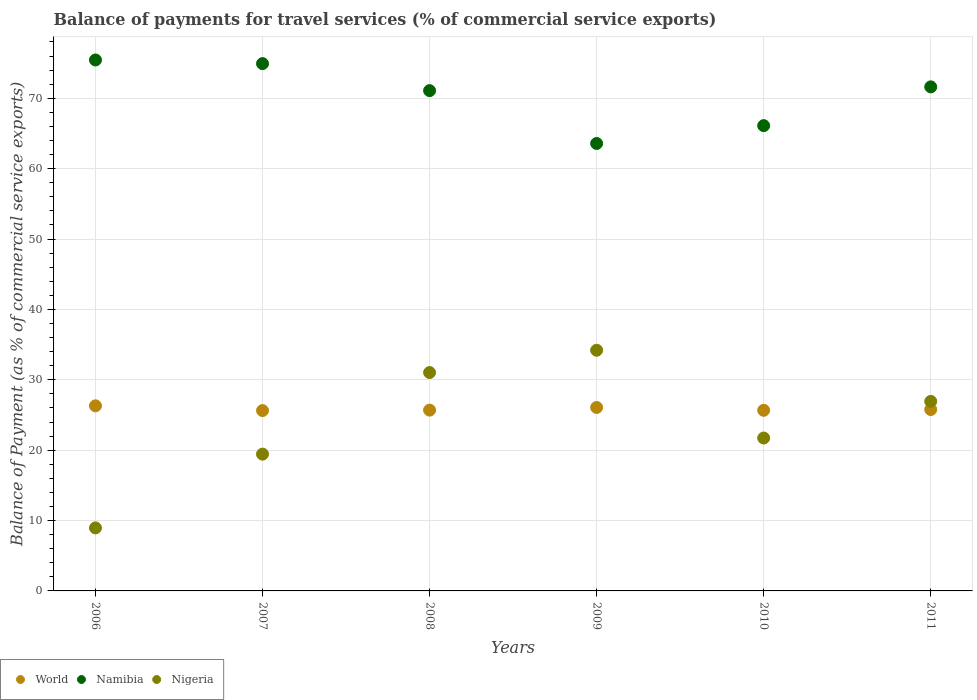How many different coloured dotlines are there?
Your response must be concise. 3. Is the number of dotlines equal to the number of legend labels?
Provide a succinct answer. Yes. What is the balance of payments for travel services in Namibia in 2009?
Keep it short and to the point. 63.58. Across all years, what is the maximum balance of payments for travel services in Nigeria?
Your response must be concise. 34.2. Across all years, what is the minimum balance of payments for travel services in Nigeria?
Make the answer very short. 8.96. In which year was the balance of payments for travel services in Namibia maximum?
Make the answer very short. 2006. In which year was the balance of payments for travel services in Nigeria minimum?
Make the answer very short. 2006. What is the total balance of payments for travel services in World in the graph?
Offer a terse response. 155.12. What is the difference between the balance of payments for travel services in Nigeria in 2008 and that in 2011?
Provide a succinct answer. 4.1. What is the difference between the balance of payments for travel services in World in 2011 and the balance of payments for travel services in Nigeria in 2008?
Your response must be concise. -5.25. What is the average balance of payments for travel services in Nigeria per year?
Make the answer very short. 23.71. In the year 2010, what is the difference between the balance of payments for travel services in World and balance of payments for travel services in Namibia?
Your response must be concise. -40.45. What is the ratio of the balance of payments for travel services in Namibia in 2006 to that in 2011?
Give a very brief answer. 1.05. Is the balance of payments for travel services in Namibia in 2009 less than that in 2011?
Ensure brevity in your answer.  Yes. What is the difference between the highest and the second highest balance of payments for travel services in Nigeria?
Keep it short and to the point. 3.17. What is the difference between the highest and the lowest balance of payments for travel services in Nigeria?
Keep it short and to the point. 25.24. Is the sum of the balance of payments for travel services in Nigeria in 2009 and 2011 greater than the maximum balance of payments for travel services in World across all years?
Give a very brief answer. Yes. Is it the case that in every year, the sum of the balance of payments for travel services in World and balance of payments for travel services in Nigeria  is greater than the balance of payments for travel services in Namibia?
Offer a terse response. No. Does the balance of payments for travel services in Namibia monotonically increase over the years?
Your response must be concise. No. Is the balance of payments for travel services in Namibia strictly less than the balance of payments for travel services in Nigeria over the years?
Give a very brief answer. No. How many years are there in the graph?
Provide a short and direct response. 6. What is the difference between two consecutive major ticks on the Y-axis?
Your answer should be very brief. 10. Are the values on the major ticks of Y-axis written in scientific E-notation?
Your response must be concise. No. Where does the legend appear in the graph?
Make the answer very short. Bottom left. How are the legend labels stacked?
Provide a succinct answer. Horizontal. What is the title of the graph?
Your answer should be very brief. Balance of payments for travel services (% of commercial service exports). What is the label or title of the X-axis?
Your answer should be very brief. Years. What is the label or title of the Y-axis?
Provide a succinct answer. Balance of Payment (as % of commercial service exports). What is the Balance of Payment (as % of commercial service exports) in World in 2006?
Provide a succinct answer. 26.3. What is the Balance of Payment (as % of commercial service exports) in Namibia in 2006?
Provide a succinct answer. 75.44. What is the Balance of Payment (as % of commercial service exports) in Nigeria in 2006?
Provide a succinct answer. 8.96. What is the Balance of Payment (as % of commercial service exports) in World in 2007?
Your answer should be very brief. 25.63. What is the Balance of Payment (as % of commercial service exports) of Namibia in 2007?
Your answer should be compact. 74.93. What is the Balance of Payment (as % of commercial service exports) in Nigeria in 2007?
Provide a short and direct response. 19.44. What is the Balance of Payment (as % of commercial service exports) in World in 2008?
Offer a terse response. 25.69. What is the Balance of Payment (as % of commercial service exports) of Namibia in 2008?
Your answer should be very brief. 71.09. What is the Balance of Payment (as % of commercial service exports) in Nigeria in 2008?
Your answer should be very brief. 31.03. What is the Balance of Payment (as % of commercial service exports) of World in 2009?
Make the answer very short. 26.07. What is the Balance of Payment (as % of commercial service exports) of Namibia in 2009?
Your answer should be compact. 63.58. What is the Balance of Payment (as % of commercial service exports) of Nigeria in 2009?
Your answer should be compact. 34.2. What is the Balance of Payment (as % of commercial service exports) of World in 2010?
Offer a very short reply. 25.66. What is the Balance of Payment (as % of commercial service exports) of Namibia in 2010?
Offer a very short reply. 66.11. What is the Balance of Payment (as % of commercial service exports) in Nigeria in 2010?
Your answer should be very brief. 21.73. What is the Balance of Payment (as % of commercial service exports) of World in 2011?
Your answer should be compact. 25.77. What is the Balance of Payment (as % of commercial service exports) of Namibia in 2011?
Provide a succinct answer. 71.62. What is the Balance of Payment (as % of commercial service exports) in Nigeria in 2011?
Your response must be concise. 26.93. Across all years, what is the maximum Balance of Payment (as % of commercial service exports) in World?
Ensure brevity in your answer.  26.3. Across all years, what is the maximum Balance of Payment (as % of commercial service exports) of Namibia?
Make the answer very short. 75.44. Across all years, what is the maximum Balance of Payment (as % of commercial service exports) in Nigeria?
Ensure brevity in your answer.  34.2. Across all years, what is the minimum Balance of Payment (as % of commercial service exports) in World?
Provide a short and direct response. 25.63. Across all years, what is the minimum Balance of Payment (as % of commercial service exports) of Namibia?
Your answer should be very brief. 63.58. Across all years, what is the minimum Balance of Payment (as % of commercial service exports) of Nigeria?
Your answer should be very brief. 8.96. What is the total Balance of Payment (as % of commercial service exports) in World in the graph?
Your response must be concise. 155.12. What is the total Balance of Payment (as % of commercial service exports) in Namibia in the graph?
Offer a terse response. 422.77. What is the total Balance of Payment (as % of commercial service exports) in Nigeria in the graph?
Your response must be concise. 142.28. What is the difference between the Balance of Payment (as % of commercial service exports) in World in 2006 and that in 2007?
Keep it short and to the point. 0.68. What is the difference between the Balance of Payment (as % of commercial service exports) of Namibia in 2006 and that in 2007?
Your answer should be very brief. 0.52. What is the difference between the Balance of Payment (as % of commercial service exports) in Nigeria in 2006 and that in 2007?
Offer a very short reply. -10.48. What is the difference between the Balance of Payment (as % of commercial service exports) in World in 2006 and that in 2008?
Give a very brief answer. 0.61. What is the difference between the Balance of Payment (as % of commercial service exports) of Namibia in 2006 and that in 2008?
Offer a very short reply. 4.36. What is the difference between the Balance of Payment (as % of commercial service exports) in Nigeria in 2006 and that in 2008?
Your answer should be very brief. -22.07. What is the difference between the Balance of Payment (as % of commercial service exports) of World in 2006 and that in 2009?
Provide a short and direct response. 0.24. What is the difference between the Balance of Payment (as % of commercial service exports) of Namibia in 2006 and that in 2009?
Provide a succinct answer. 11.86. What is the difference between the Balance of Payment (as % of commercial service exports) of Nigeria in 2006 and that in 2009?
Offer a terse response. -25.24. What is the difference between the Balance of Payment (as % of commercial service exports) in World in 2006 and that in 2010?
Offer a terse response. 0.64. What is the difference between the Balance of Payment (as % of commercial service exports) in Namibia in 2006 and that in 2010?
Provide a short and direct response. 9.33. What is the difference between the Balance of Payment (as % of commercial service exports) of Nigeria in 2006 and that in 2010?
Your response must be concise. -12.77. What is the difference between the Balance of Payment (as % of commercial service exports) of World in 2006 and that in 2011?
Make the answer very short. 0.53. What is the difference between the Balance of Payment (as % of commercial service exports) of Namibia in 2006 and that in 2011?
Keep it short and to the point. 3.82. What is the difference between the Balance of Payment (as % of commercial service exports) of Nigeria in 2006 and that in 2011?
Provide a succinct answer. -17.98. What is the difference between the Balance of Payment (as % of commercial service exports) of World in 2007 and that in 2008?
Your response must be concise. -0.06. What is the difference between the Balance of Payment (as % of commercial service exports) of Namibia in 2007 and that in 2008?
Provide a succinct answer. 3.84. What is the difference between the Balance of Payment (as % of commercial service exports) of Nigeria in 2007 and that in 2008?
Your response must be concise. -11.59. What is the difference between the Balance of Payment (as % of commercial service exports) of World in 2007 and that in 2009?
Your answer should be very brief. -0.44. What is the difference between the Balance of Payment (as % of commercial service exports) of Namibia in 2007 and that in 2009?
Your response must be concise. 11.35. What is the difference between the Balance of Payment (as % of commercial service exports) in Nigeria in 2007 and that in 2009?
Ensure brevity in your answer.  -14.76. What is the difference between the Balance of Payment (as % of commercial service exports) in World in 2007 and that in 2010?
Provide a short and direct response. -0.04. What is the difference between the Balance of Payment (as % of commercial service exports) of Namibia in 2007 and that in 2010?
Offer a very short reply. 8.81. What is the difference between the Balance of Payment (as % of commercial service exports) in Nigeria in 2007 and that in 2010?
Keep it short and to the point. -2.29. What is the difference between the Balance of Payment (as % of commercial service exports) in World in 2007 and that in 2011?
Keep it short and to the point. -0.15. What is the difference between the Balance of Payment (as % of commercial service exports) in Namibia in 2007 and that in 2011?
Your answer should be very brief. 3.3. What is the difference between the Balance of Payment (as % of commercial service exports) of Nigeria in 2007 and that in 2011?
Provide a succinct answer. -7.5. What is the difference between the Balance of Payment (as % of commercial service exports) in World in 2008 and that in 2009?
Your answer should be compact. -0.38. What is the difference between the Balance of Payment (as % of commercial service exports) of Namibia in 2008 and that in 2009?
Ensure brevity in your answer.  7.51. What is the difference between the Balance of Payment (as % of commercial service exports) of Nigeria in 2008 and that in 2009?
Your answer should be very brief. -3.17. What is the difference between the Balance of Payment (as % of commercial service exports) in World in 2008 and that in 2010?
Offer a very short reply. 0.03. What is the difference between the Balance of Payment (as % of commercial service exports) in Namibia in 2008 and that in 2010?
Your answer should be compact. 4.97. What is the difference between the Balance of Payment (as % of commercial service exports) in Nigeria in 2008 and that in 2010?
Your response must be concise. 9.3. What is the difference between the Balance of Payment (as % of commercial service exports) in World in 2008 and that in 2011?
Make the answer very short. -0.09. What is the difference between the Balance of Payment (as % of commercial service exports) of Namibia in 2008 and that in 2011?
Your answer should be very brief. -0.53. What is the difference between the Balance of Payment (as % of commercial service exports) of Nigeria in 2008 and that in 2011?
Give a very brief answer. 4.1. What is the difference between the Balance of Payment (as % of commercial service exports) in World in 2009 and that in 2010?
Ensure brevity in your answer.  0.4. What is the difference between the Balance of Payment (as % of commercial service exports) in Namibia in 2009 and that in 2010?
Your response must be concise. -2.53. What is the difference between the Balance of Payment (as % of commercial service exports) of Nigeria in 2009 and that in 2010?
Give a very brief answer. 12.47. What is the difference between the Balance of Payment (as % of commercial service exports) of World in 2009 and that in 2011?
Ensure brevity in your answer.  0.29. What is the difference between the Balance of Payment (as % of commercial service exports) of Namibia in 2009 and that in 2011?
Your response must be concise. -8.04. What is the difference between the Balance of Payment (as % of commercial service exports) of Nigeria in 2009 and that in 2011?
Keep it short and to the point. 7.27. What is the difference between the Balance of Payment (as % of commercial service exports) of World in 2010 and that in 2011?
Provide a short and direct response. -0.11. What is the difference between the Balance of Payment (as % of commercial service exports) of Namibia in 2010 and that in 2011?
Keep it short and to the point. -5.51. What is the difference between the Balance of Payment (as % of commercial service exports) in Nigeria in 2010 and that in 2011?
Make the answer very short. -5.21. What is the difference between the Balance of Payment (as % of commercial service exports) of World in 2006 and the Balance of Payment (as % of commercial service exports) of Namibia in 2007?
Make the answer very short. -48.62. What is the difference between the Balance of Payment (as % of commercial service exports) of World in 2006 and the Balance of Payment (as % of commercial service exports) of Nigeria in 2007?
Your response must be concise. 6.87. What is the difference between the Balance of Payment (as % of commercial service exports) in Namibia in 2006 and the Balance of Payment (as % of commercial service exports) in Nigeria in 2007?
Offer a very short reply. 56.01. What is the difference between the Balance of Payment (as % of commercial service exports) of World in 2006 and the Balance of Payment (as % of commercial service exports) of Namibia in 2008?
Keep it short and to the point. -44.78. What is the difference between the Balance of Payment (as % of commercial service exports) of World in 2006 and the Balance of Payment (as % of commercial service exports) of Nigeria in 2008?
Provide a succinct answer. -4.73. What is the difference between the Balance of Payment (as % of commercial service exports) of Namibia in 2006 and the Balance of Payment (as % of commercial service exports) of Nigeria in 2008?
Offer a very short reply. 44.41. What is the difference between the Balance of Payment (as % of commercial service exports) of World in 2006 and the Balance of Payment (as % of commercial service exports) of Namibia in 2009?
Keep it short and to the point. -37.28. What is the difference between the Balance of Payment (as % of commercial service exports) of World in 2006 and the Balance of Payment (as % of commercial service exports) of Nigeria in 2009?
Give a very brief answer. -7.9. What is the difference between the Balance of Payment (as % of commercial service exports) of Namibia in 2006 and the Balance of Payment (as % of commercial service exports) of Nigeria in 2009?
Your answer should be very brief. 41.25. What is the difference between the Balance of Payment (as % of commercial service exports) in World in 2006 and the Balance of Payment (as % of commercial service exports) in Namibia in 2010?
Keep it short and to the point. -39.81. What is the difference between the Balance of Payment (as % of commercial service exports) of World in 2006 and the Balance of Payment (as % of commercial service exports) of Nigeria in 2010?
Your response must be concise. 4.58. What is the difference between the Balance of Payment (as % of commercial service exports) of Namibia in 2006 and the Balance of Payment (as % of commercial service exports) of Nigeria in 2010?
Provide a succinct answer. 53.72. What is the difference between the Balance of Payment (as % of commercial service exports) of World in 2006 and the Balance of Payment (as % of commercial service exports) of Namibia in 2011?
Provide a succinct answer. -45.32. What is the difference between the Balance of Payment (as % of commercial service exports) of World in 2006 and the Balance of Payment (as % of commercial service exports) of Nigeria in 2011?
Your response must be concise. -0.63. What is the difference between the Balance of Payment (as % of commercial service exports) of Namibia in 2006 and the Balance of Payment (as % of commercial service exports) of Nigeria in 2011?
Keep it short and to the point. 48.51. What is the difference between the Balance of Payment (as % of commercial service exports) of World in 2007 and the Balance of Payment (as % of commercial service exports) of Namibia in 2008?
Provide a succinct answer. -45.46. What is the difference between the Balance of Payment (as % of commercial service exports) of World in 2007 and the Balance of Payment (as % of commercial service exports) of Nigeria in 2008?
Give a very brief answer. -5.4. What is the difference between the Balance of Payment (as % of commercial service exports) of Namibia in 2007 and the Balance of Payment (as % of commercial service exports) of Nigeria in 2008?
Offer a very short reply. 43.9. What is the difference between the Balance of Payment (as % of commercial service exports) of World in 2007 and the Balance of Payment (as % of commercial service exports) of Namibia in 2009?
Offer a terse response. -37.95. What is the difference between the Balance of Payment (as % of commercial service exports) of World in 2007 and the Balance of Payment (as % of commercial service exports) of Nigeria in 2009?
Keep it short and to the point. -8.57. What is the difference between the Balance of Payment (as % of commercial service exports) of Namibia in 2007 and the Balance of Payment (as % of commercial service exports) of Nigeria in 2009?
Provide a short and direct response. 40.73. What is the difference between the Balance of Payment (as % of commercial service exports) in World in 2007 and the Balance of Payment (as % of commercial service exports) in Namibia in 2010?
Ensure brevity in your answer.  -40.49. What is the difference between the Balance of Payment (as % of commercial service exports) in World in 2007 and the Balance of Payment (as % of commercial service exports) in Nigeria in 2010?
Your answer should be compact. 3.9. What is the difference between the Balance of Payment (as % of commercial service exports) in Namibia in 2007 and the Balance of Payment (as % of commercial service exports) in Nigeria in 2010?
Ensure brevity in your answer.  53.2. What is the difference between the Balance of Payment (as % of commercial service exports) of World in 2007 and the Balance of Payment (as % of commercial service exports) of Namibia in 2011?
Keep it short and to the point. -45.99. What is the difference between the Balance of Payment (as % of commercial service exports) of World in 2007 and the Balance of Payment (as % of commercial service exports) of Nigeria in 2011?
Provide a succinct answer. -1.31. What is the difference between the Balance of Payment (as % of commercial service exports) of Namibia in 2007 and the Balance of Payment (as % of commercial service exports) of Nigeria in 2011?
Your answer should be very brief. 47.99. What is the difference between the Balance of Payment (as % of commercial service exports) of World in 2008 and the Balance of Payment (as % of commercial service exports) of Namibia in 2009?
Ensure brevity in your answer.  -37.89. What is the difference between the Balance of Payment (as % of commercial service exports) in World in 2008 and the Balance of Payment (as % of commercial service exports) in Nigeria in 2009?
Your answer should be very brief. -8.51. What is the difference between the Balance of Payment (as % of commercial service exports) of Namibia in 2008 and the Balance of Payment (as % of commercial service exports) of Nigeria in 2009?
Offer a terse response. 36.89. What is the difference between the Balance of Payment (as % of commercial service exports) of World in 2008 and the Balance of Payment (as % of commercial service exports) of Namibia in 2010?
Make the answer very short. -40.42. What is the difference between the Balance of Payment (as % of commercial service exports) in World in 2008 and the Balance of Payment (as % of commercial service exports) in Nigeria in 2010?
Your answer should be very brief. 3.96. What is the difference between the Balance of Payment (as % of commercial service exports) in Namibia in 2008 and the Balance of Payment (as % of commercial service exports) in Nigeria in 2010?
Provide a short and direct response. 49.36. What is the difference between the Balance of Payment (as % of commercial service exports) of World in 2008 and the Balance of Payment (as % of commercial service exports) of Namibia in 2011?
Offer a very short reply. -45.93. What is the difference between the Balance of Payment (as % of commercial service exports) of World in 2008 and the Balance of Payment (as % of commercial service exports) of Nigeria in 2011?
Your answer should be very brief. -1.24. What is the difference between the Balance of Payment (as % of commercial service exports) of Namibia in 2008 and the Balance of Payment (as % of commercial service exports) of Nigeria in 2011?
Make the answer very short. 44.15. What is the difference between the Balance of Payment (as % of commercial service exports) of World in 2009 and the Balance of Payment (as % of commercial service exports) of Namibia in 2010?
Keep it short and to the point. -40.05. What is the difference between the Balance of Payment (as % of commercial service exports) in World in 2009 and the Balance of Payment (as % of commercial service exports) in Nigeria in 2010?
Make the answer very short. 4.34. What is the difference between the Balance of Payment (as % of commercial service exports) in Namibia in 2009 and the Balance of Payment (as % of commercial service exports) in Nigeria in 2010?
Your response must be concise. 41.85. What is the difference between the Balance of Payment (as % of commercial service exports) in World in 2009 and the Balance of Payment (as % of commercial service exports) in Namibia in 2011?
Your response must be concise. -45.55. What is the difference between the Balance of Payment (as % of commercial service exports) in World in 2009 and the Balance of Payment (as % of commercial service exports) in Nigeria in 2011?
Ensure brevity in your answer.  -0.87. What is the difference between the Balance of Payment (as % of commercial service exports) of Namibia in 2009 and the Balance of Payment (as % of commercial service exports) of Nigeria in 2011?
Your answer should be very brief. 36.65. What is the difference between the Balance of Payment (as % of commercial service exports) of World in 2010 and the Balance of Payment (as % of commercial service exports) of Namibia in 2011?
Provide a short and direct response. -45.96. What is the difference between the Balance of Payment (as % of commercial service exports) in World in 2010 and the Balance of Payment (as % of commercial service exports) in Nigeria in 2011?
Make the answer very short. -1.27. What is the difference between the Balance of Payment (as % of commercial service exports) in Namibia in 2010 and the Balance of Payment (as % of commercial service exports) in Nigeria in 2011?
Your answer should be compact. 39.18. What is the average Balance of Payment (as % of commercial service exports) in World per year?
Keep it short and to the point. 25.85. What is the average Balance of Payment (as % of commercial service exports) of Namibia per year?
Your answer should be very brief. 70.46. What is the average Balance of Payment (as % of commercial service exports) in Nigeria per year?
Provide a succinct answer. 23.71. In the year 2006, what is the difference between the Balance of Payment (as % of commercial service exports) in World and Balance of Payment (as % of commercial service exports) in Namibia?
Your answer should be compact. -49.14. In the year 2006, what is the difference between the Balance of Payment (as % of commercial service exports) of World and Balance of Payment (as % of commercial service exports) of Nigeria?
Give a very brief answer. 17.35. In the year 2006, what is the difference between the Balance of Payment (as % of commercial service exports) of Namibia and Balance of Payment (as % of commercial service exports) of Nigeria?
Your response must be concise. 66.49. In the year 2007, what is the difference between the Balance of Payment (as % of commercial service exports) in World and Balance of Payment (as % of commercial service exports) in Namibia?
Offer a terse response. -49.3. In the year 2007, what is the difference between the Balance of Payment (as % of commercial service exports) of World and Balance of Payment (as % of commercial service exports) of Nigeria?
Provide a succinct answer. 6.19. In the year 2007, what is the difference between the Balance of Payment (as % of commercial service exports) of Namibia and Balance of Payment (as % of commercial service exports) of Nigeria?
Provide a succinct answer. 55.49. In the year 2008, what is the difference between the Balance of Payment (as % of commercial service exports) of World and Balance of Payment (as % of commercial service exports) of Namibia?
Provide a short and direct response. -45.4. In the year 2008, what is the difference between the Balance of Payment (as % of commercial service exports) of World and Balance of Payment (as % of commercial service exports) of Nigeria?
Provide a short and direct response. -5.34. In the year 2008, what is the difference between the Balance of Payment (as % of commercial service exports) in Namibia and Balance of Payment (as % of commercial service exports) in Nigeria?
Give a very brief answer. 40.06. In the year 2009, what is the difference between the Balance of Payment (as % of commercial service exports) in World and Balance of Payment (as % of commercial service exports) in Namibia?
Give a very brief answer. -37.51. In the year 2009, what is the difference between the Balance of Payment (as % of commercial service exports) of World and Balance of Payment (as % of commercial service exports) of Nigeria?
Your response must be concise. -8.13. In the year 2009, what is the difference between the Balance of Payment (as % of commercial service exports) of Namibia and Balance of Payment (as % of commercial service exports) of Nigeria?
Keep it short and to the point. 29.38. In the year 2010, what is the difference between the Balance of Payment (as % of commercial service exports) in World and Balance of Payment (as % of commercial service exports) in Namibia?
Offer a terse response. -40.45. In the year 2010, what is the difference between the Balance of Payment (as % of commercial service exports) of World and Balance of Payment (as % of commercial service exports) of Nigeria?
Provide a succinct answer. 3.94. In the year 2010, what is the difference between the Balance of Payment (as % of commercial service exports) of Namibia and Balance of Payment (as % of commercial service exports) of Nigeria?
Offer a terse response. 44.39. In the year 2011, what is the difference between the Balance of Payment (as % of commercial service exports) of World and Balance of Payment (as % of commercial service exports) of Namibia?
Your answer should be very brief. -45.85. In the year 2011, what is the difference between the Balance of Payment (as % of commercial service exports) of World and Balance of Payment (as % of commercial service exports) of Nigeria?
Give a very brief answer. -1.16. In the year 2011, what is the difference between the Balance of Payment (as % of commercial service exports) of Namibia and Balance of Payment (as % of commercial service exports) of Nigeria?
Your answer should be compact. 44.69. What is the ratio of the Balance of Payment (as % of commercial service exports) of World in 2006 to that in 2007?
Provide a succinct answer. 1.03. What is the ratio of the Balance of Payment (as % of commercial service exports) of Namibia in 2006 to that in 2007?
Your answer should be compact. 1.01. What is the ratio of the Balance of Payment (as % of commercial service exports) in Nigeria in 2006 to that in 2007?
Make the answer very short. 0.46. What is the ratio of the Balance of Payment (as % of commercial service exports) in World in 2006 to that in 2008?
Keep it short and to the point. 1.02. What is the ratio of the Balance of Payment (as % of commercial service exports) of Namibia in 2006 to that in 2008?
Your answer should be very brief. 1.06. What is the ratio of the Balance of Payment (as % of commercial service exports) in Nigeria in 2006 to that in 2008?
Offer a terse response. 0.29. What is the ratio of the Balance of Payment (as % of commercial service exports) in Namibia in 2006 to that in 2009?
Your answer should be very brief. 1.19. What is the ratio of the Balance of Payment (as % of commercial service exports) in Nigeria in 2006 to that in 2009?
Make the answer very short. 0.26. What is the ratio of the Balance of Payment (as % of commercial service exports) in World in 2006 to that in 2010?
Ensure brevity in your answer.  1.02. What is the ratio of the Balance of Payment (as % of commercial service exports) in Namibia in 2006 to that in 2010?
Keep it short and to the point. 1.14. What is the ratio of the Balance of Payment (as % of commercial service exports) in Nigeria in 2006 to that in 2010?
Your response must be concise. 0.41. What is the ratio of the Balance of Payment (as % of commercial service exports) of World in 2006 to that in 2011?
Offer a terse response. 1.02. What is the ratio of the Balance of Payment (as % of commercial service exports) in Namibia in 2006 to that in 2011?
Ensure brevity in your answer.  1.05. What is the ratio of the Balance of Payment (as % of commercial service exports) of Nigeria in 2006 to that in 2011?
Provide a succinct answer. 0.33. What is the ratio of the Balance of Payment (as % of commercial service exports) of World in 2007 to that in 2008?
Provide a succinct answer. 1. What is the ratio of the Balance of Payment (as % of commercial service exports) in Namibia in 2007 to that in 2008?
Give a very brief answer. 1.05. What is the ratio of the Balance of Payment (as % of commercial service exports) in Nigeria in 2007 to that in 2008?
Ensure brevity in your answer.  0.63. What is the ratio of the Balance of Payment (as % of commercial service exports) of World in 2007 to that in 2009?
Your answer should be compact. 0.98. What is the ratio of the Balance of Payment (as % of commercial service exports) in Namibia in 2007 to that in 2009?
Your answer should be compact. 1.18. What is the ratio of the Balance of Payment (as % of commercial service exports) of Nigeria in 2007 to that in 2009?
Provide a succinct answer. 0.57. What is the ratio of the Balance of Payment (as % of commercial service exports) in World in 2007 to that in 2010?
Give a very brief answer. 1. What is the ratio of the Balance of Payment (as % of commercial service exports) of Namibia in 2007 to that in 2010?
Keep it short and to the point. 1.13. What is the ratio of the Balance of Payment (as % of commercial service exports) in Nigeria in 2007 to that in 2010?
Your answer should be compact. 0.89. What is the ratio of the Balance of Payment (as % of commercial service exports) of Namibia in 2007 to that in 2011?
Provide a succinct answer. 1.05. What is the ratio of the Balance of Payment (as % of commercial service exports) in Nigeria in 2007 to that in 2011?
Offer a very short reply. 0.72. What is the ratio of the Balance of Payment (as % of commercial service exports) of World in 2008 to that in 2009?
Provide a succinct answer. 0.99. What is the ratio of the Balance of Payment (as % of commercial service exports) in Namibia in 2008 to that in 2009?
Offer a terse response. 1.12. What is the ratio of the Balance of Payment (as % of commercial service exports) in Nigeria in 2008 to that in 2009?
Offer a very short reply. 0.91. What is the ratio of the Balance of Payment (as % of commercial service exports) of Namibia in 2008 to that in 2010?
Your answer should be very brief. 1.08. What is the ratio of the Balance of Payment (as % of commercial service exports) in Nigeria in 2008 to that in 2010?
Ensure brevity in your answer.  1.43. What is the ratio of the Balance of Payment (as % of commercial service exports) in Nigeria in 2008 to that in 2011?
Your response must be concise. 1.15. What is the ratio of the Balance of Payment (as % of commercial service exports) of World in 2009 to that in 2010?
Provide a short and direct response. 1.02. What is the ratio of the Balance of Payment (as % of commercial service exports) of Namibia in 2009 to that in 2010?
Provide a succinct answer. 0.96. What is the ratio of the Balance of Payment (as % of commercial service exports) in Nigeria in 2009 to that in 2010?
Ensure brevity in your answer.  1.57. What is the ratio of the Balance of Payment (as % of commercial service exports) in World in 2009 to that in 2011?
Ensure brevity in your answer.  1.01. What is the ratio of the Balance of Payment (as % of commercial service exports) of Namibia in 2009 to that in 2011?
Make the answer very short. 0.89. What is the ratio of the Balance of Payment (as % of commercial service exports) of Nigeria in 2009 to that in 2011?
Your answer should be very brief. 1.27. What is the ratio of the Balance of Payment (as % of commercial service exports) in Namibia in 2010 to that in 2011?
Keep it short and to the point. 0.92. What is the ratio of the Balance of Payment (as % of commercial service exports) of Nigeria in 2010 to that in 2011?
Offer a very short reply. 0.81. What is the difference between the highest and the second highest Balance of Payment (as % of commercial service exports) of World?
Provide a succinct answer. 0.24. What is the difference between the highest and the second highest Balance of Payment (as % of commercial service exports) of Namibia?
Offer a very short reply. 0.52. What is the difference between the highest and the second highest Balance of Payment (as % of commercial service exports) in Nigeria?
Offer a very short reply. 3.17. What is the difference between the highest and the lowest Balance of Payment (as % of commercial service exports) of World?
Provide a succinct answer. 0.68. What is the difference between the highest and the lowest Balance of Payment (as % of commercial service exports) of Namibia?
Provide a succinct answer. 11.86. What is the difference between the highest and the lowest Balance of Payment (as % of commercial service exports) of Nigeria?
Ensure brevity in your answer.  25.24. 